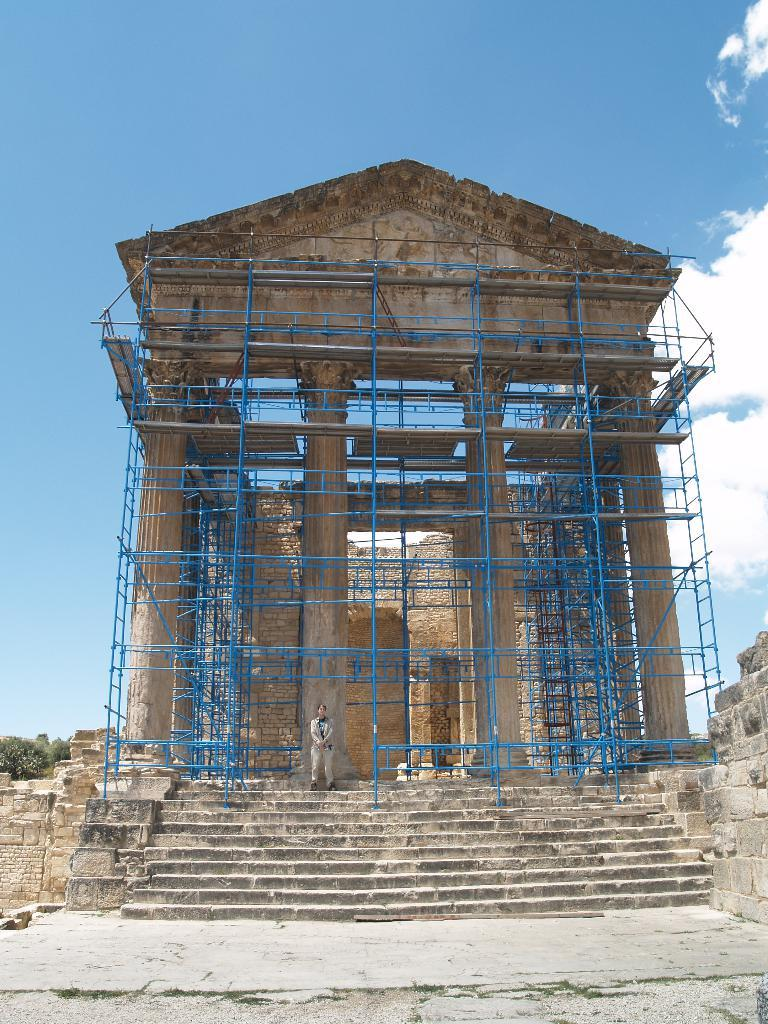What is the main subject of the image? The main subject of the image is a building under construction in the center of the image. Can you describe the woman visible at the bottom of the image? A woman is visible at the bottom of the image, but her specific features or actions are not described in the provided facts. What architectural feature is present at the bottom of the image? There are stairs at the bottom of the image. What can be seen in the background of the image? Trees, the sky, and clouds are visible in the background of the image. What type of knowledge does the skate have about the construction process? There is no skate present in the image, and therefore no such knowledge can be attributed to it. 